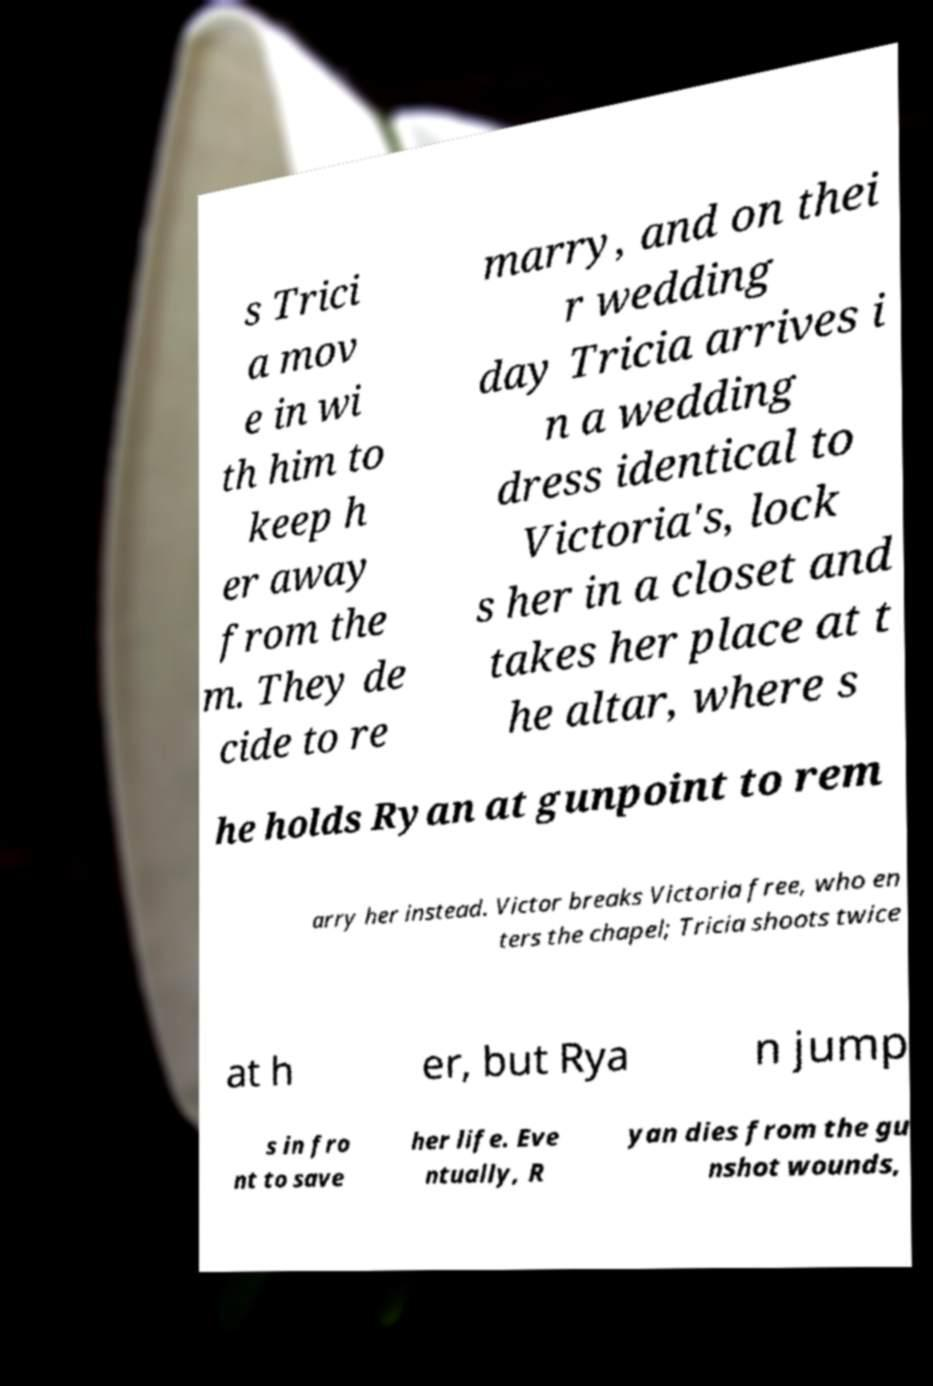Please read and relay the text visible in this image. What does it say? s Trici a mov e in wi th him to keep h er away from the m. They de cide to re marry, and on thei r wedding day Tricia arrives i n a wedding dress identical to Victoria's, lock s her in a closet and takes her place at t he altar, where s he holds Ryan at gunpoint to rem arry her instead. Victor breaks Victoria free, who en ters the chapel; Tricia shoots twice at h er, but Rya n jump s in fro nt to save her life. Eve ntually, R yan dies from the gu nshot wounds, 